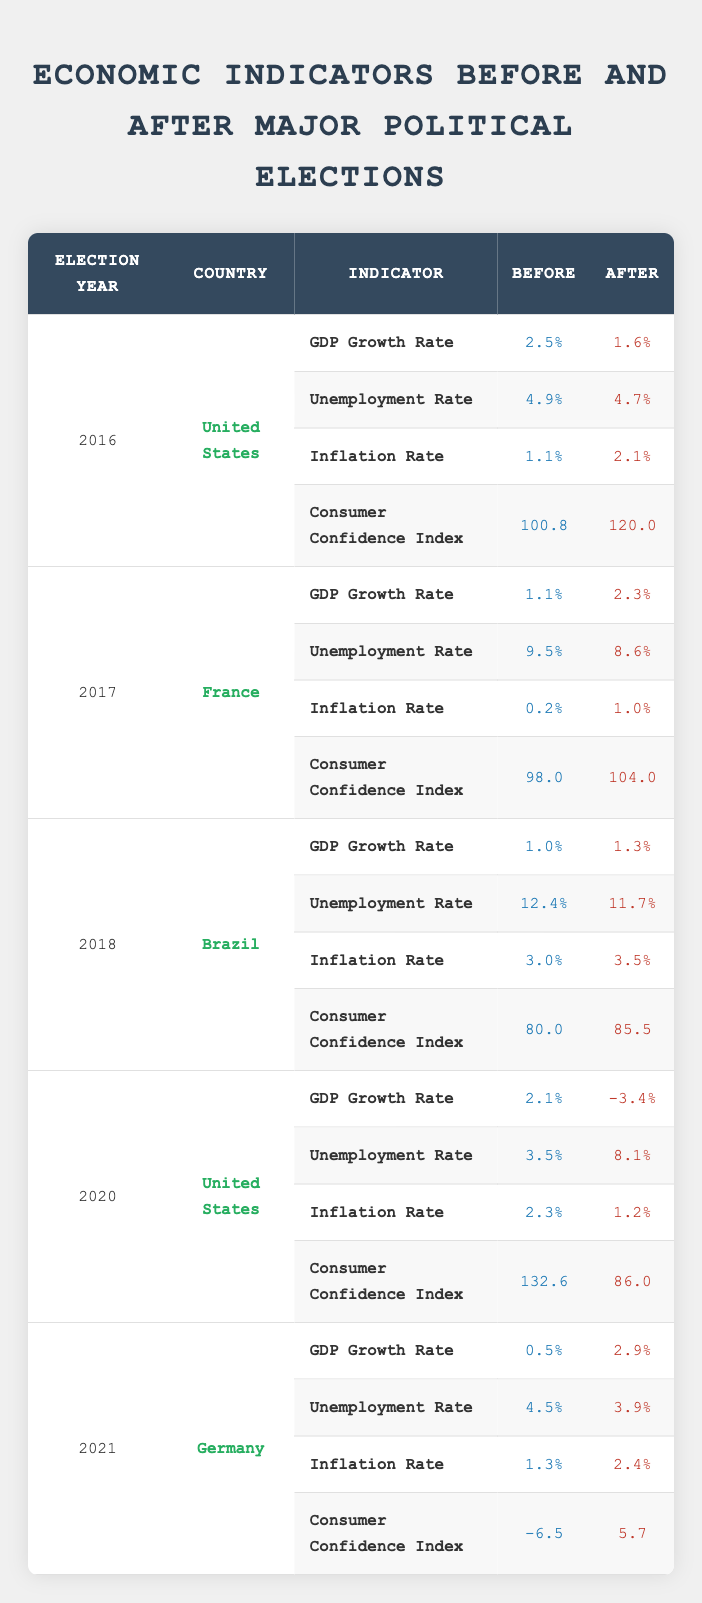What was the GDP growth rate before the 2016 election in the United States? The GDP growth rate before the 2016 election in the United States is listed in the table as 2.5%. This value can be directly retrieved from the specified row of the table.
Answer: 2.5% What was the change in the consumer confidence index in France from before to after the 2017 election? To determine the change, subtract the consumer confidence index before the election (98.0) from the index after the election (104.0): 104.0 - 98.0 = 6.0. This calculation shows that the index increased by 6.0.
Answer: 6.0 Was the unemployment rate higher after the 2020 election in the United States compared to before? The unemployment rate before the 2020 election was 3.5%, while it rose to 8.1% after the election. Since 8.1% is greater than 3.5%, the answer is yes.
Answer: Yes What was the inflation rate in Brazil before the 2018 election, and did it increase after the election? The inflation rate in Brazil before the 2018 election was 3.0%. After the election, it increased to 3.5%. This indicates a rise of 0.5%. Therefore, the inflation rate did increase.
Answer: Yes Calculate the average GDP growth rate after the elections for all countries listed. The GDP growth rates after the elections are: 1.6 (US 2016), 2.3 (France 2017), 1.3 (Brazil 2018), -3.4 (US 2020), 2.9 (Germany 2021). To find the average, sum these values (1.6 + 2.3 + 1.3 - 3.4 + 2.9 = 4.7) and divide by the number of data points (5): 4.7 / 5 = 0.94.
Answer: 0.94 Did the inflation rate in Germany after the 2021 election exceed 2%? According to the table, the inflation rate in Germany after the 2021 election is listed as 2.4%. Since 2.4% is greater than 2%, the answer is yes.
Answer: Yes 